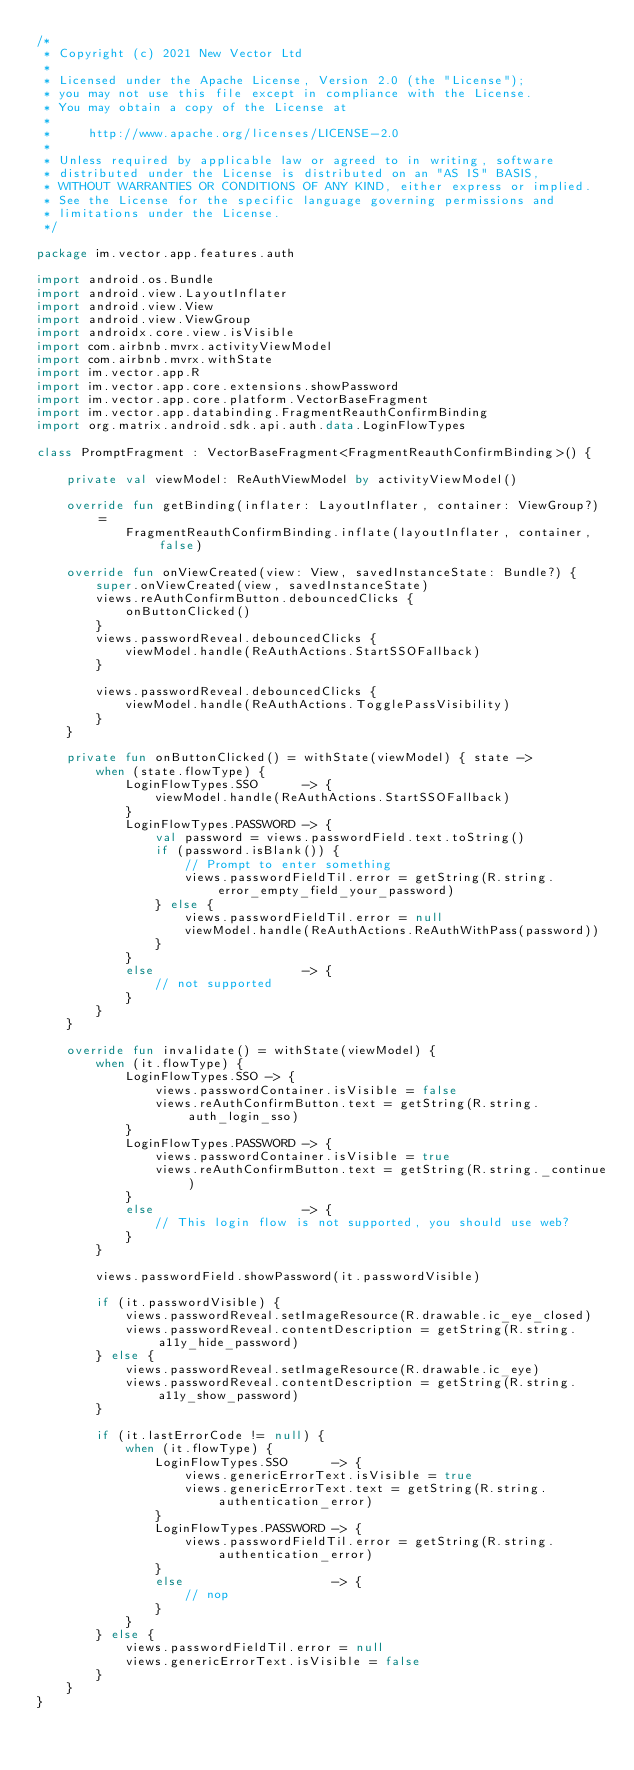Convert code to text. <code><loc_0><loc_0><loc_500><loc_500><_Kotlin_>/*
 * Copyright (c) 2021 New Vector Ltd
 *
 * Licensed under the Apache License, Version 2.0 (the "License");
 * you may not use this file except in compliance with the License.
 * You may obtain a copy of the License at
 *
 *     http://www.apache.org/licenses/LICENSE-2.0
 *
 * Unless required by applicable law or agreed to in writing, software
 * distributed under the License is distributed on an "AS IS" BASIS,
 * WITHOUT WARRANTIES OR CONDITIONS OF ANY KIND, either express or implied.
 * See the License for the specific language governing permissions and
 * limitations under the License.
 */

package im.vector.app.features.auth

import android.os.Bundle
import android.view.LayoutInflater
import android.view.View
import android.view.ViewGroup
import androidx.core.view.isVisible
import com.airbnb.mvrx.activityViewModel
import com.airbnb.mvrx.withState
import im.vector.app.R
import im.vector.app.core.extensions.showPassword
import im.vector.app.core.platform.VectorBaseFragment
import im.vector.app.databinding.FragmentReauthConfirmBinding
import org.matrix.android.sdk.api.auth.data.LoginFlowTypes

class PromptFragment : VectorBaseFragment<FragmentReauthConfirmBinding>() {

    private val viewModel: ReAuthViewModel by activityViewModel()

    override fun getBinding(inflater: LayoutInflater, container: ViewGroup?) =
            FragmentReauthConfirmBinding.inflate(layoutInflater, container, false)

    override fun onViewCreated(view: View, savedInstanceState: Bundle?) {
        super.onViewCreated(view, savedInstanceState)
        views.reAuthConfirmButton.debouncedClicks {
            onButtonClicked()
        }
        views.passwordReveal.debouncedClicks {
            viewModel.handle(ReAuthActions.StartSSOFallback)
        }

        views.passwordReveal.debouncedClicks {
            viewModel.handle(ReAuthActions.TogglePassVisibility)
        }
    }

    private fun onButtonClicked() = withState(viewModel) { state ->
        when (state.flowType) {
            LoginFlowTypes.SSO      -> {
                viewModel.handle(ReAuthActions.StartSSOFallback)
            }
            LoginFlowTypes.PASSWORD -> {
                val password = views.passwordField.text.toString()
                if (password.isBlank()) {
                    // Prompt to enter something
                    views.passwordFieldTil.error = getString(R.string.error_empty_field_your_password)
                } else {
                    views.passwordFieldTil.error = null
                    viewModel.handle(ReAuthActions.ReAuthWithPass(password))
                }
            }
            else                    -> {
                // not supported
            }
        }
    }

    override fun invalidate() = withState(viewModel) {
        when (it.flowType) {
            LoginFlowTypes.SSO -> {
                views.passwordContainer.isVisible = false
                views.reAuthConfirmButton.text = getString(R.string.auth_login_sso)
            }
            LoginFlowTypes.PASSWORD -> {
                views.passwordContainer.isVisible = true
                views.reAuthConfirmButton.text = getString(R.string._continue)
            }
            else                    -> {
                // This login flow is not supported, you should use web?
            }
        }

        views.passwordField.showPassword(it.passwordVisible)

        if (it.passwordVisible) {
            views.passwordReveal.setImageResource(R.drawable.ic_eye_closed)
            views.passwordReveal.contentDescription = getString(R.string.a11y_hide_password)
        } else {
            views.passwordReveal.setImageResource(R.drawable.ic_eye)
            views.passwordReveal.contentDescription = getString(R.string.a11y_show_password)
        }

        if (it.lastErrorCode != null) {
            when (it.flowType) {
                LoginFlowTypes.SSO      -> {
                    views.genericErrorText.isVisible = true
                    views.genericErrorText.text = getString(R.string.authentication_error)
                }
                LoginFlowTypes.PASSWORD -> {
                    views.passwordFieldTil.error = getString(R.string.authentication_error)
                }
                else                    -> {
                    // nop
                }
            }
        } else {
            views.passwordFieldTil.error = null
            views.genericErrorText.isVisible = false
        }
    }
}
</code> 